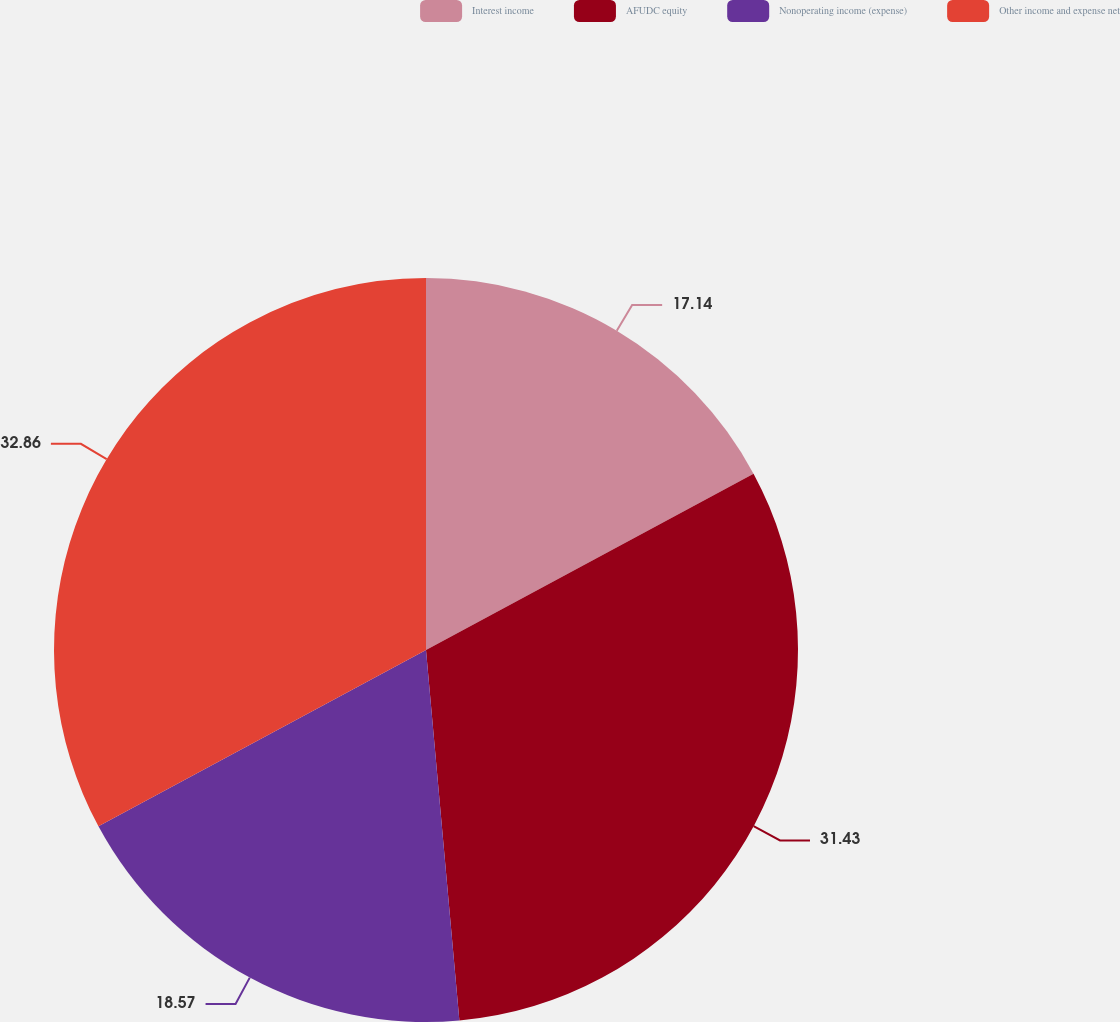Convert chart to OTSL. <chart><loc_0><loc_0><loc_500><loc_500><pie_chart><fcel>Interest income<fcel>AFUDC equity<fcel>Nonoperating income (expense)<fcel>Other income and expense net<nl><fcel>17.14%<fcel>31.43%<fcel>18.57%<fcel>32.86%<nl></chart> 